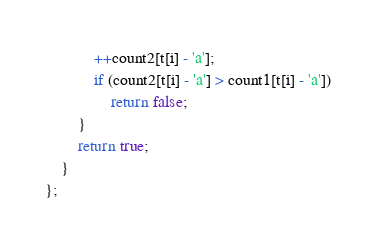<code> <loc_0><loc_0><loc_500><loc_500><_C++_>            ++count2[t[i] - 'a'];
            if (count2[t[i] - 'a'] > count1[t[i] - 'a'])
                return false;
        }
        return true;
    }
};</code> 